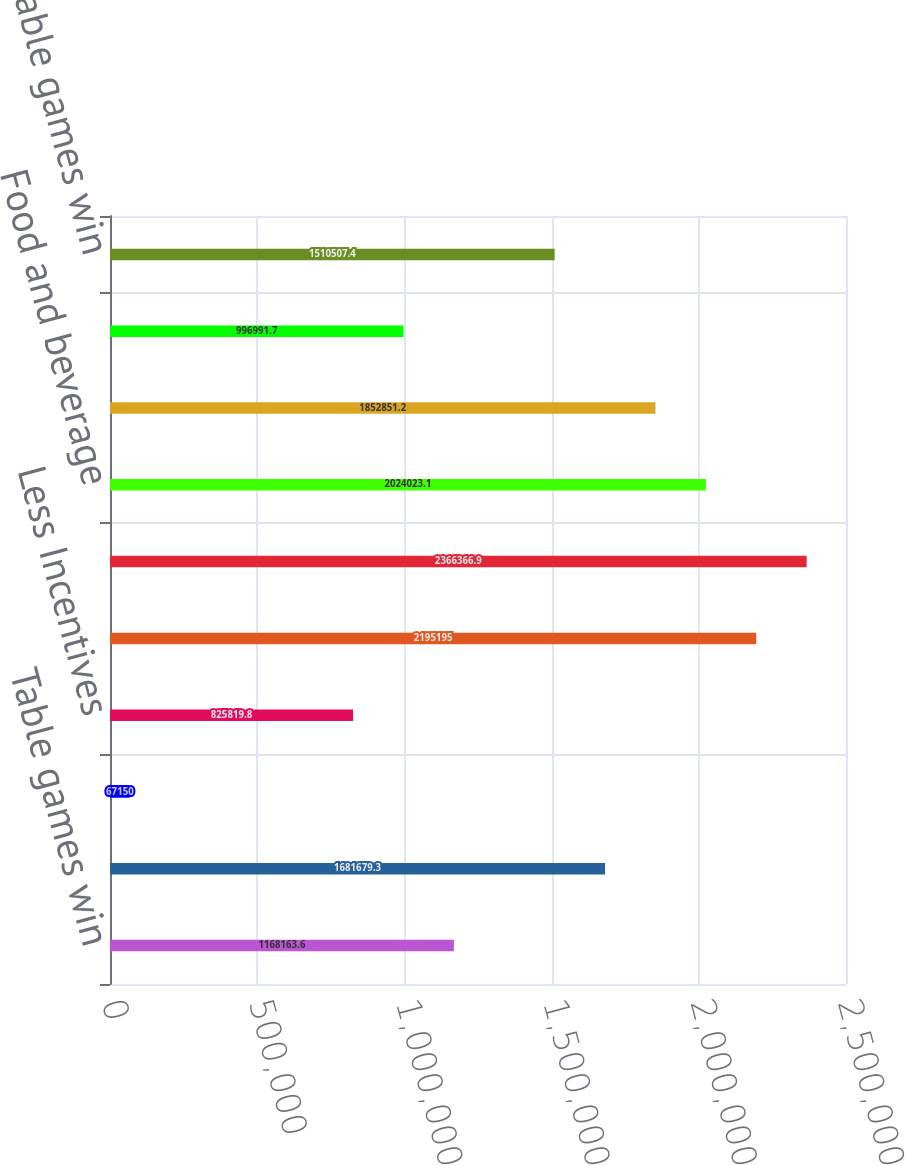<chart> <loc_0><loc_0><loc_500><loc_500><bar_chart><fcel>Table games win<fcel>Slots win<fcel>Other<fcel>Less Incentives<fcel>Casino revenue<fcel>Rooms<fcel>Food and beverage<fcel>Entertainment retail and other<fcel>Non-casino revenue<fcel>VIP table games win<nl><fcel>1.16816e+06<fcel>1.68168e+06<fcel>67150<fcel>825820<fcel>2.1952e+06<fcel>2.36637e+06<fcel>2.02402e+06<fcel>1.85285e+06<fcel>996992<fcel>1.51051e+06<nl></chart> 